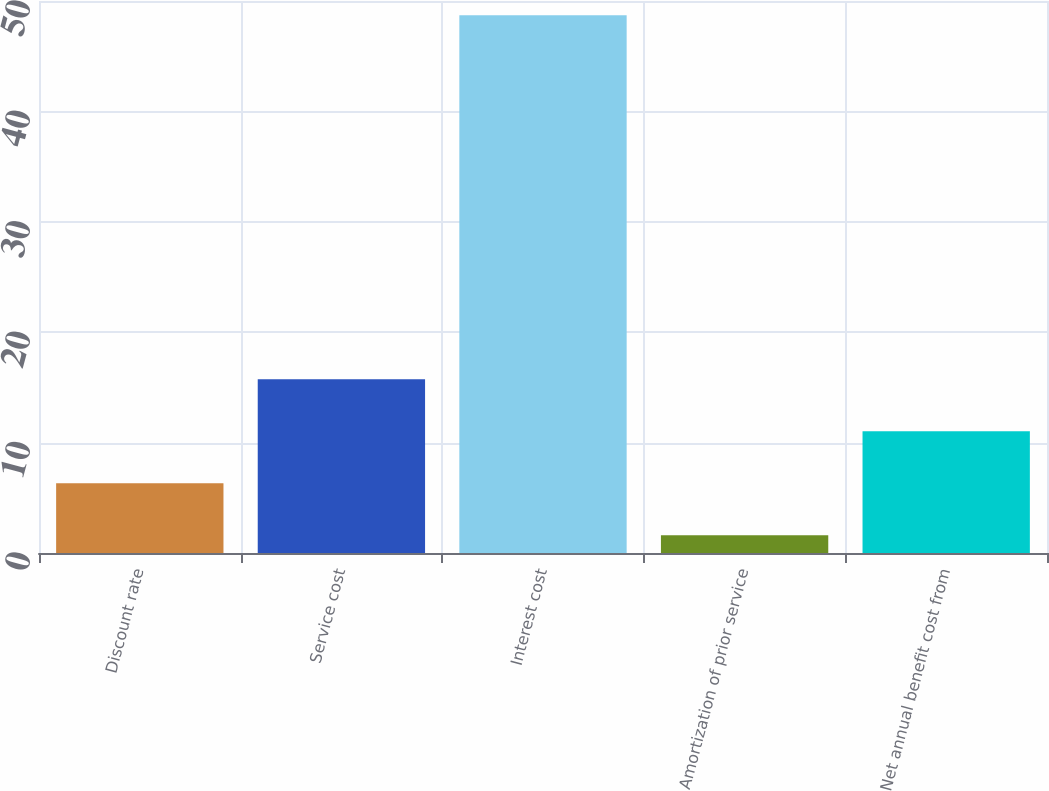Convert chart to OTSL. <chart><loc_0><loc_0><loc_500><loc_500><bar_chart><fcel>Discount rate<fcel>Service cost<fcel>Interest cost<fcel>Amortization of prior service<fcel>Net annual benefit cost from<nl><fcel>6.31<fcel>15.73<fcel>48.7<fcel>1.6<fcel>11.02<nl></chart> 